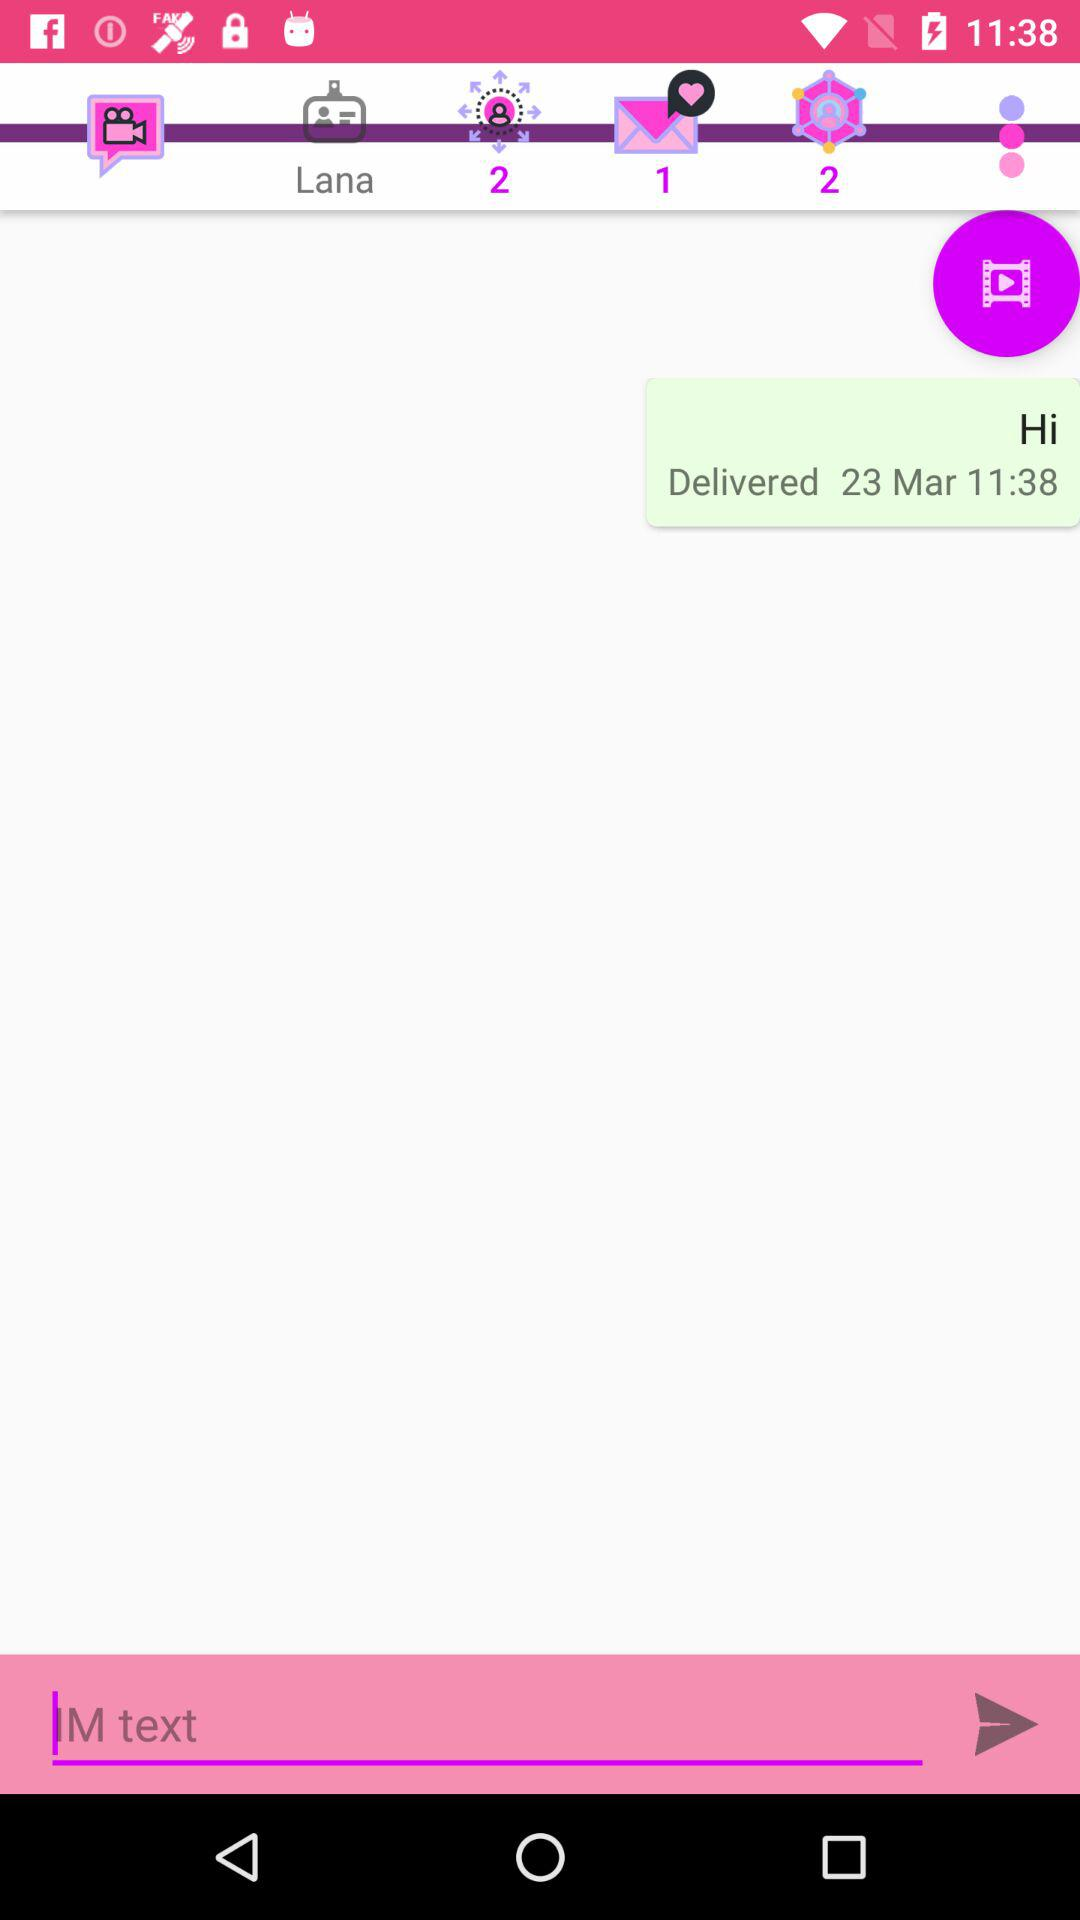What is the time of message delivery? The time for the message delivery is 11:38. 